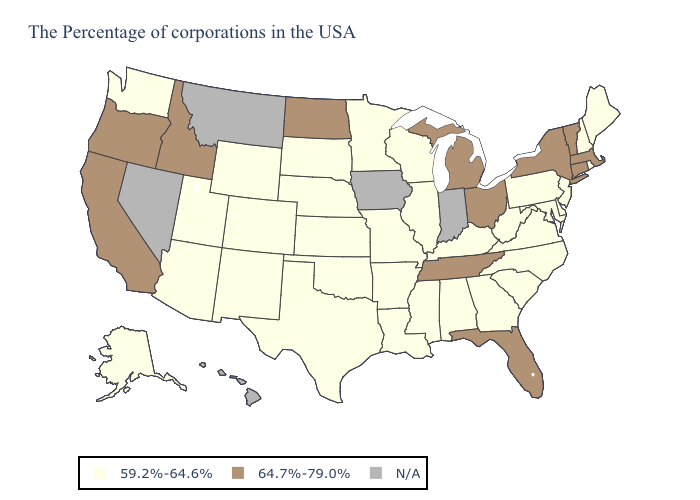How many symbols are there in the legend?
Keep it brief. 3. Which states hav the highest value in the South?
Answer briefly. Florida, Tennessee. Name the states that have a value in the range 64.7%-79.0%?
Keep it brief. Massachusetts, Vermont, Connecticut, New York, Ohio, Florida, Michigan, Tennessee, North Dakota, Idaho, California, Oregon. What is the highest value in the USA?
Short answer required. 64.7%-79.0%. What is the lowest value in states that border Utah?
Concise answer only. 59.2%-64.6%. Name the states that have a value in the range 64.7%-79.0%?
Answer briefly. Massachusetts, Vermont, Connecticut, New York, Ohio, Florida, Michigan, Tennessee, North Dakota, Idaho, California, Oregon. Name the states that have a value in the range 59.2%-64.6%?
Short answer required. Maine, Rhode Island, New Hampshire, New Jersey, Delaware, Maryland, Pennsylvania, Virginia, North Carolina, South Carolina, West Virginia, Georgia, Kentucky, Alabama, Wisconsin, Illinois, Mississippi, Louisiana, Missouri, Arkansas, Minnesota, Kansas, Nebraska, Oklahoma, Texas, South Dakota, Wyoming, Colorado, New Mexico, Utah, Arizona, Washington, Alaska. Name the states that have a value in the range 59.2%-64.6%?
Write a very short answer. Maine, Rhode Island, New Hampshire, New Jersey, Delaware, Maryland, Pennsylvania, Virginia, North Carolina, South Carolina, West Virginia, Georgia, Kentucky, Alabama, Wisconsin, Illinois, Mississippi, Louisiana, Missouri, Arkansas, Minnesota, Kansas, Nebraska, Oklahoma, Texas, South Dakota, Wyoming, Colorado, New Mexico, Utah, Arizona, Washington, Alaska. Does Idaho have the lowest value in the USA?
Be succinct. No. What is the highest value in the USA?
Write a very short answer. 64.7%-79.0%. Name the states that have a value in the range N/A?
Write a very short answer. Indiana, Iowa, Montana, Nevada, Hawaii. Does the first symbol in the legend represent the smallest category?
Give a very brief answer. Yes. How many symbols are there in the legend?
Concise answer only. 3. Which states have the lowest value in the Northeast?
Concise answer only. Maine, Rhode Island, New Hampshire, New Jersey, Pennsylvania. 